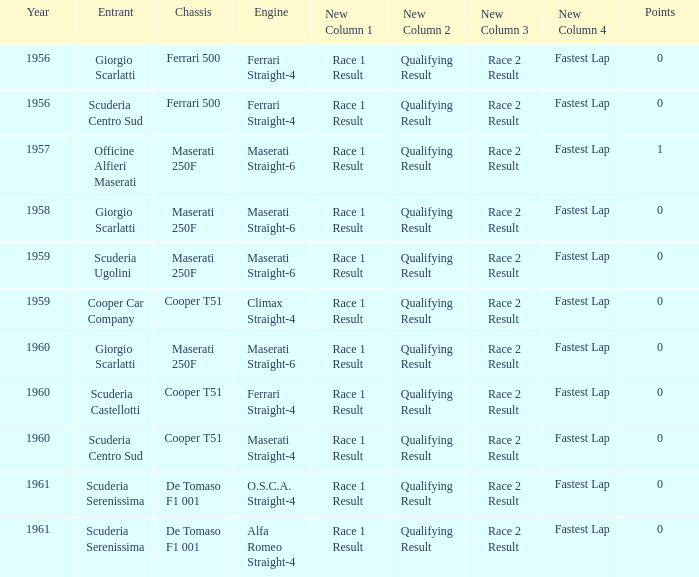How many points for the cooper car company after 1959? None. 